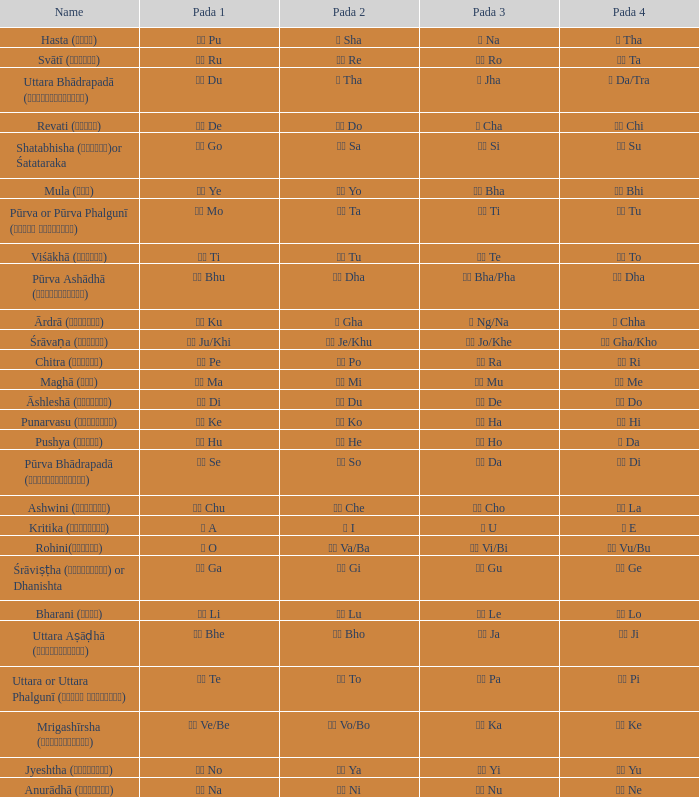What kind of Pada 1 has a Pada 2 of सा sa? गो Go. 